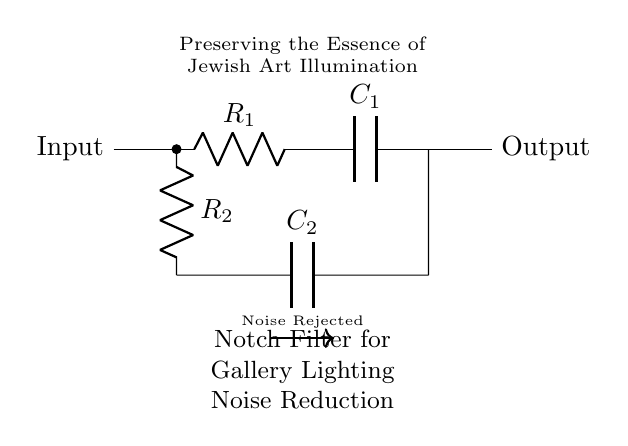What type of filter is shown in this circuit? The circuit is a notch filter, which is designed to reject a specific frequency while allowing others to pass through. This is indicated by the label in the diagram.
Answer: Notch filter What are the two resistors in the circuit? The resistors are identified as R1 and R2, both labeled within the circuit diagram. R1 is connected in series with the input, while R2 is paired with the capacitor in a parallel arrangement.
Answer: R1 and R2 What is the purpose of the capacitors in this circuit? The capacitors C1 and C2 are used in the filter to store and release charge which helps in defining the frequency response of the notch filter. C1 is involved in the main signal path, while C2 is part of the feedback loop for noise rejection.
Answer: Noise reduction How does the circuit reject noise? The notch filter rejects noise by resonating at a specific frequency defined by the values of R1, R2, and C1, while allowing frequencies outside of this notch to pass through, effectively eliminating unwanted signals.
Answer: By resonating at a specific frequency What is the input and output of the circuit? The input terminal is labeled on the left side of the diagram and the output terminal on the right side, indicating where the processed signal enters and exits the filter.
Answer: Input and Output What is the significance of this filter for exhibitions? The significance lies in its purpose to maintain the quality of the lighting in exhibitions by eliminating electrical noise, thereby preserving the visual integrity of the Jewish artworks displayed.
Answer: Art illumination 